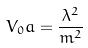Convert formula to latex. <formula><loc_0><loc_0><loc_500><loc_500>V _ { 0 } a = \frac { \lambda ^ { 2 } } { m ^ { 2 } }</formula> 